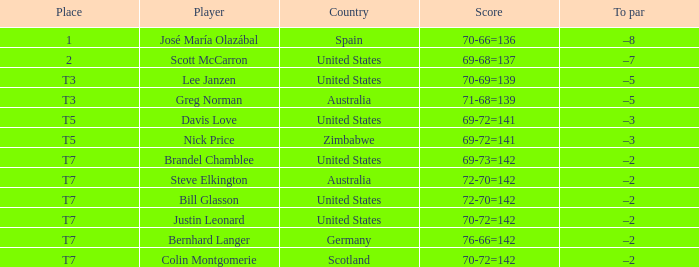From the united states, which score has a -3 top par? 69-72=141. 